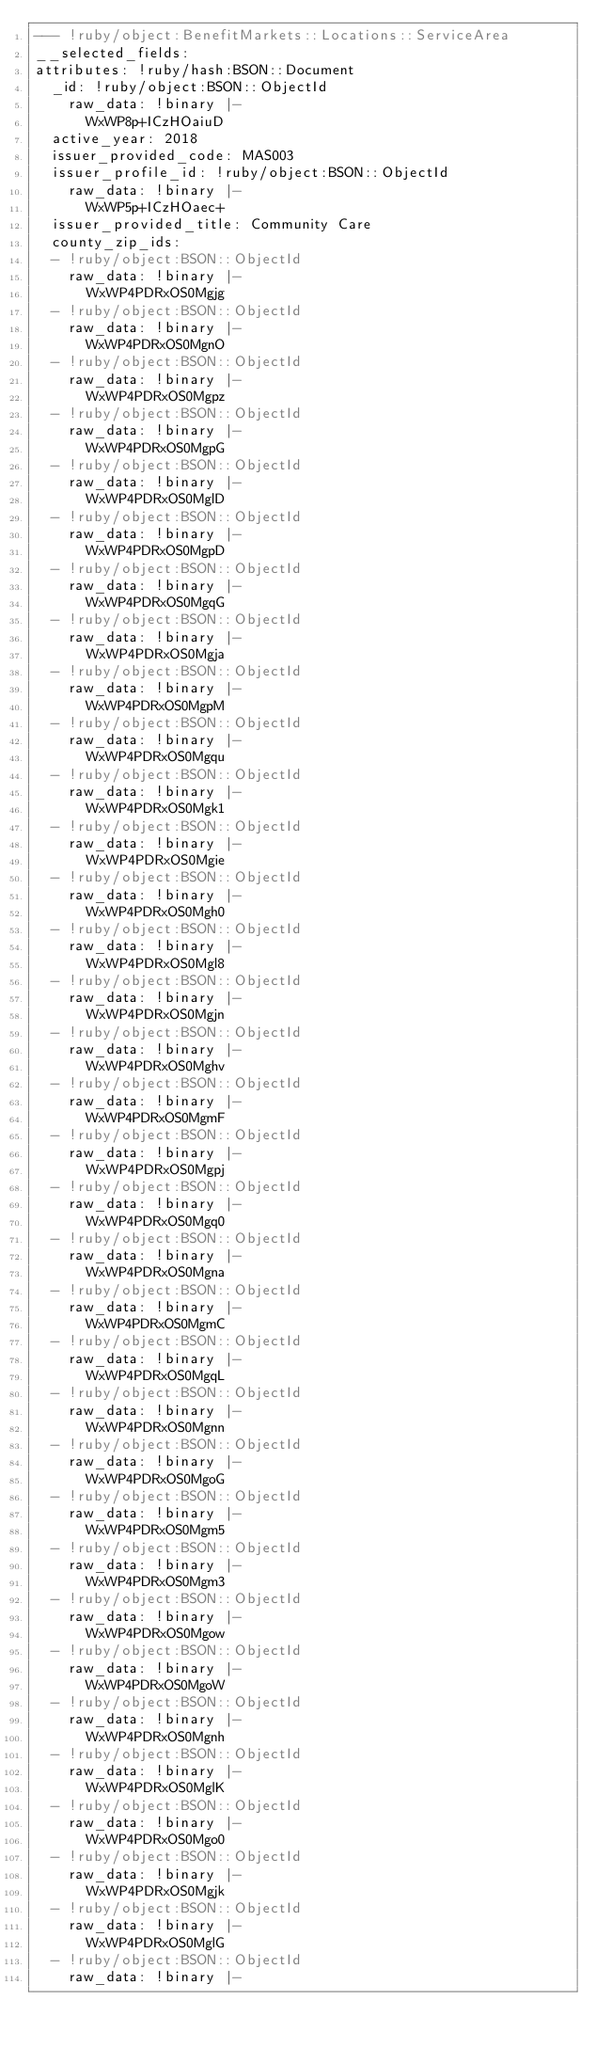Convert code to text. <code><loc_0><loc_0><loc_500><loc_500><_YAML_>--- !ruby/object:BenefitMarkets::Locations::ServiceArea
__selected_fields: 
attributes: !ruby/hash:BSON::Document
  _id: !ruby/object:BSON::ObjectId
    raw_data: !binary |-
      WxWP8p+ICzHOaiuD
  active_year: 2018
  issuer_provided_code: MAS003
  issuer_profile_id: !ruby/object:BSON::ObjectId
    raw_data: !binary |-
      WxWP5p+ICzHOaec+
  issuer_provided_title: Community Care
  county_zip_ids:
  - !ruby/object:BSON::ObjectId
    raw_data: !binary |-
      WxWP4PDRxOS0Mgjg
  - !ruby/object:BSON::ObjectId
    raw_data: !binary |-
      WxWP4PDRxOS0MgnO
  - !ruby/object:BSON::ObjectId
    raw_data: !binary |-
      WxWP4PDRxOS0Mgpz
  - !ruby/object:BSON::ObjectId
    raw_data: !binary |-
      WxWP4PDRxOS0MgpG
  - !ruby/object:BSON::ObjectId
    raw_data: !binary |-
      WxWP4PDRxOS0MglD
  - !ruby/object:BSON::ObjectId
    raw_data: !binary |-
      WxWP4PDRxOS0MgpD
  - !ruby/object:BSON::ObjectId
    raw_data: !binary |-
      WxWP4PDRxOS0MgqG
  - !ruby/object:BSON::ObjectId
    raw_data: !binary |-
      WxWP4PDRxOS0Mgja
  - !ruby/object:BSON::ObjectId
    raw_data: !binary |-
      WxWP4PDRxOS0MgpM
  - !ruby/object:BSON::ObjectId
    raw_data: !binary |-
      WxWP4PDRxOS0Mgqu
  - !ruby/object:BSON::ObjectId
    raw_data: !binary |-
      WxWP4PDRxOS0Mgk1
  - !ruby/object:BSON::ObjectId
    raw_data: !binary |-
      WxWP4PDRxOS0Mgie
  - !ruby/object:BSON::ObjectId
    raw_data: !binary |-
      WxWP4PDRxOS0Mgh0
  - !ruby/object:BSON::ObjectId
    raw_data: !binary |-
      WxWP4PDRxOS0Mgl8
  - !ruby/object:BSON::ObjectId
    raw_data: !binary |-
      WxWP4PDRxOS0Mgjn
  - !ruby/object:BSON::ObjectId
    raw_data: !binary |-
      WxWP4PDRxOS0Mghv
  - !ruby/object:BSON::ObjectId
    raw_data: !binary |-
      WxWP4PDRxOS0MgmF
  - !ruby/object:BSON::ObjectId
    raw_data: !binary |-
      WxWP4PDRxOS0Mgpj
  - !ruby/object:BSON::ObjectId
    raw_data: !binary |-
      WxWP4PDRxOS0Mgq0
  - !ruby/object:BSON::ObjectId
    raw_data: !binary |-
      WxWP4PDRxOS0Mgna
  - !ruby/object:BSON::ObjectId
    raw_data: !binary |-
      WxWP4PDRxOS0MgmC
  - !ruby/object:BSON::ObjectId
    raw_data: !binary |-
      WxWP4PDRxOS0MgqL
  - !ruby/object:BSON::ObjectId
    raw_data: !binary |-
      WxWP4PDRxOS0Mgnn
  - !ruby/object:BSON::ObjectId
    raw_data: !binary |-
      WxWP4PDRxOS0MgoG
  - !ruby/object:BSON::ObjectId
    raw_data: !binary |-
      WxWP4PDRxOS0Mgm5
  - !ruby/object:BSON::ObjectId
    raw_data: !binary |-
      WxWP4PDRxOS0Mgm3
  - !ruby/object:BSON::ObjectId
    raw_data: !binary |-
      WxWP4PDRxOS0Mgow
  - !ruby/object:BSON::ObjectId
    raw_data: !binary |-
      WxWP4PDRxOS0MgoW
  - !ruby/object:BSON::ObjectId
    raw_data: !binary |-
      WxWP4PDRxOS0Mgnh
  - !ruby/object:BSON::ObjectId
    raw_data: !binary |-
      WxWP4PDRxOS0MglK
  - !ruby/object:BSON::ObjectId
    raw_data: !binary |-
      WxWP4PDRxOS0Mgo0
  - !ruby/object:BSON::ObjectId
    raw_data: !binary |-
      WxWP4PDRxOS0Mgjk
  - !ruby/object:BSON::ObjectId
    raw_data: !binary |-
      WxWP4PDRxOS0MglG
  - !ruby/object:BSON::ObjectId
    raw_data: !binary |-</code> 